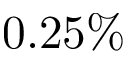Convert formula to latex. <formula><loc_0><loc_0><loc_500><loc_500>0 . 2 5 \%</formula> 